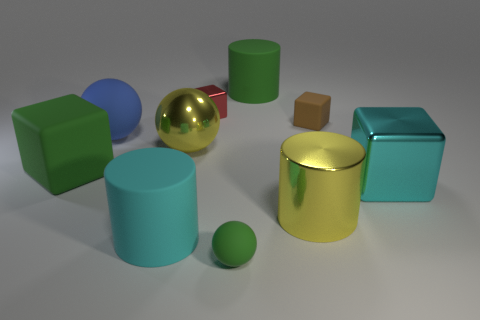Subtract all big rubber cylinders. How many cylinders are left? 1 Subtract all cyan cubes. How many cubes are left? 3 Subtract all cylinders. How many objects are left? 7 Add 3 tiny green objects. How many tiny green objects exist? 4 Subtract 0 purple spheres. How many objects are left? 10 Subtract 1 cylinders. How many cylinders are left? 2 Subtract all cyan blocks. Subtract all blue spheres. How many blocks are left? 3 Subtract all gray balls. How many brown cylinders are left? 0 Subtract all large yellow metallic things. Subtract all big shiny blocks. How many objects are left? 7 Add 6 cubes. How many cubes are left? 10 